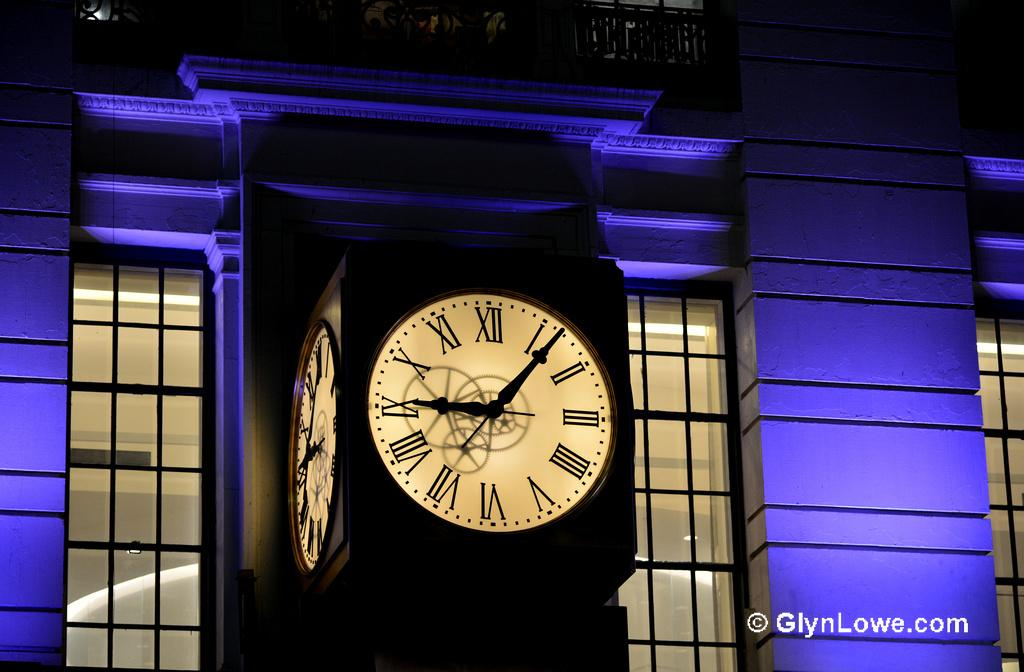<image>
Render a clear and concise summary of the photo. Large clock with the hands on 9 and the other one at 1 